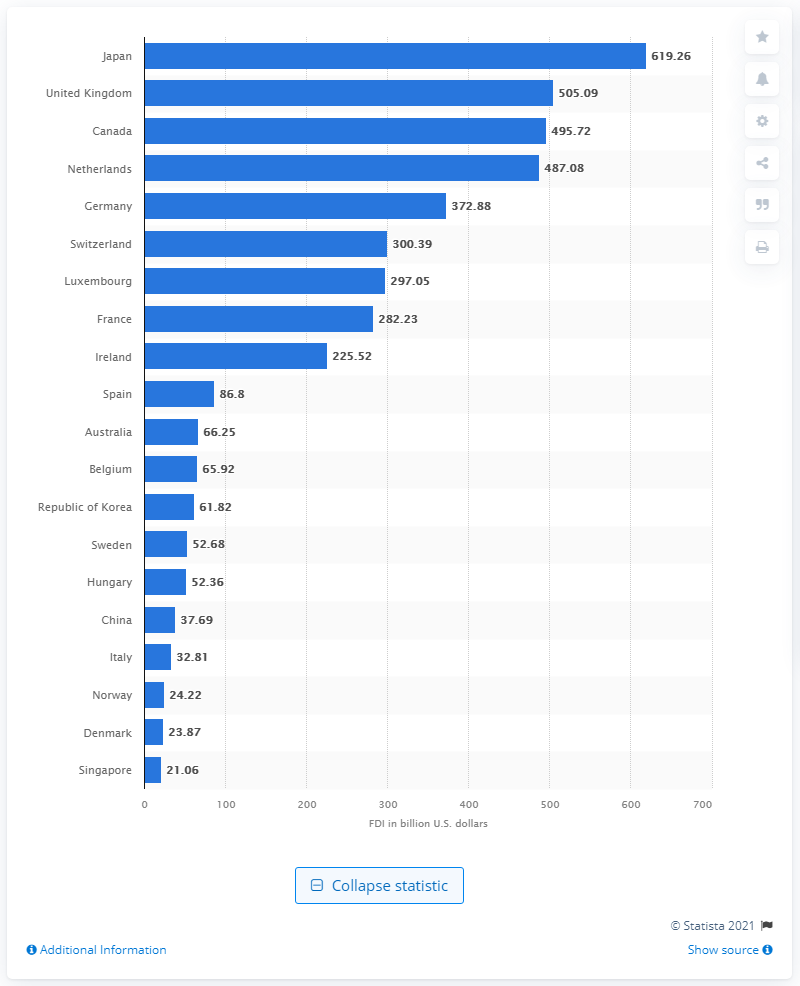Draw attention to some important aspects in this diagram. In 2019, Japan invested a total of 619.26 billion dollars in the United States. 